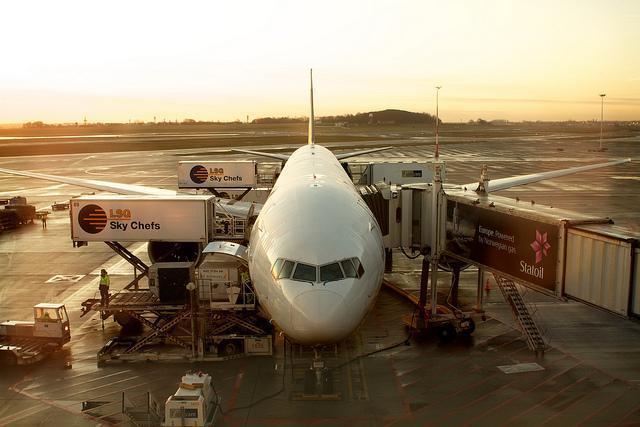How many trucks are there?
Give a very brief answer. 2. 